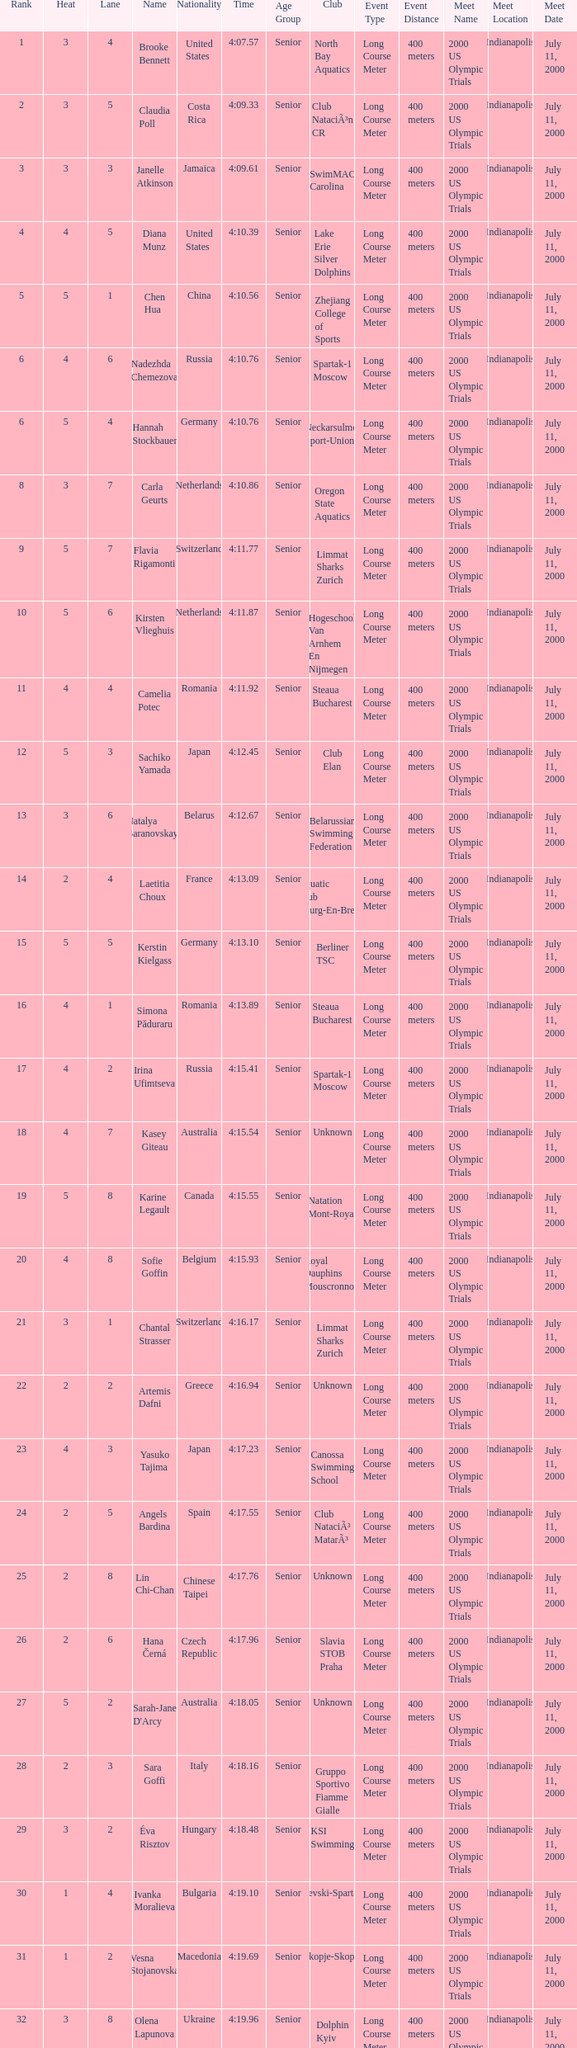Name the total number of lane for brooke bennett and rank less than 1 0.0. Give me the full table as a dictionary. {'header': ['Rank', 'Heat', 'Lane', 'Name', 'Nationality', 'Time', 'Age Group', 'Club', 'Event Type', 'Event Distance', 'Meet Name', 'Meet Location', 'Meet Date'], 'rows': [['1', '3', '4', 'Brooke Bennett', 'United States', '4:07.57', 'Senior', 'North Bay Aquatics', 'Long Course Meter', '400 meters', '2000 US Olympic Trials', 'Indianapolis', 'July 11, 2000'], ['2', '3', '5', 'Claudia Poll', 'Costa Rica', '4:09.33', 'Senior', 'Club NataciÃ³n CR', 'Long Course Meter', '400 meters', '2000 US Olympic Trials', 'Indianapolis', 'July 11, 2000'], ['3', '3', '3', 'Janelle Atkinson', 'Jamaica', '4:09.61', 'Senior', 'SwimMAC Carolina', 'Long Course Meter', '400 meters', '2000 US Olympic Trials', 'Indianapolis', 'July 11, 2000'], ['4', '4', '5', 'Diana Munz', 'United States', '4:10.39', 'Senior', 'Lake Erie Silver Dolphins', 'Long Course Meter', '400 meters', '2000 US Olympic Trials', 'Indianapolis', 'July 11, 2000'], ['5', '5', '1', 'Chen Hua', 'China', '4:10.56', 'Senior', 'Zhejiang College of Sports', 'Long Course Meter', '400 meters', '2000 US Olympic Trials', 'Indianapolis', 'July 11, 2000'], ['6', '4', '6', 'Nadezhda Chemezova', 'Russia', '4:10.76', 'Senior', 'Spartak-1 Moscow', 'Long Course Meter', '400 meters', '2000 US Olympic Trials', 'Indianapolis', 'July 11, 2000'], ['6', '5', '4', 'Hannah Stockbauer', 'Germany', '4:10.76', 'Senior', 'Neckarsulmer Sport-Union', 'Long Course Meter', '400 meters', '2000 US Olympic Trials', 'Indianapolis', 'July 11, 2000'], ['8', '3', '7', 'Carla Geurts', 'Netherlands', '4:10.86', 'Senior', 'Oregon State Aquatics', 'Long Course Meter', '400 meters', '2000 US Olympic Trials', 'Indianapolis', 'July 11, 2000'], ['9', '5', '7', 'Flavia Rigamonti', 'Switzerland', '4:11.77', 'Senior', 'Limmat Sharks Zurich', 'Long Course Meter', '400 meters', '2000 US Olympic Trials', 'Indianapolis', 'July 11, 2000'], ['10', '5', '6', 'Kirsten Vlieghuis', 'Netherlands', '4:11.87', 'Senior', 'Hogeschool Van Arnhem En Nijmegen', 'Long Course Meter', '400 meters', '2000 US Olympic Trials', 'Indianapolis', 'July 11, 2000'], ['11', '4', '4', 'Camelia Potec', 'Romania', '4:11.92', 'Senior', 'Steaua Bucharest', 'Long Course Meter', '400 meters', '2000 US Olympic Trials', 'Indianapolis', 'July 11, 2000'], ['12', '5', '3', 'Sachiko Yamada', 'Japan', '4:12.45', 'Senior', 'Club Elan', 'Long Course Meter', '400 meters', '2000 US Olympic Trials', 'Indianapolis', 'July 11, 2000'], ['13', '3', '6', 'Natalya Baranovskaya', 'Belarus', '4:12.67', 'Senior', 'Belarussian Swimming Federation', 'Long Course Meter', '400 meters', '2000 US Olympic Trials', 'Indianapolis', 'July 11, 2000'], ['14', '2', '4', 'Laetitia Choux', 'France', '4:13.09', 'Senior', 'Aquatic Club Bourg-En-Bresse', 'Long Course Meter', '400 meters', '2000 US Olympic Trials', 'Indianapolis', 'July 11, 2000'], ['15', '5', '5', 'Kerstin Kielgass', 'Germany', '4:13.10', 'Senior', 'Berliner TSC', 'Long Course Meter', '400 meters', '2000 US Olympic Trials', 'Indianapolis', 'July 11, 2000'], ['16', '4', '1', 'Simona Păduraru', 'Romania', '4:13.89', 'Senior', 'Steaua Bucharest', 'Long Course Meter', '400 meters', '2000 US Olympic Trials', 'Indianapolis', 'July 11, 2000'], ['17', '4', '2', 'Irina Ufimtseva', 'Russia', '4:15.41', 'Senior', 'Spartak-1 Moscow', 'Long Course Meter', '400 meters', '2000 US Olympic Trials', 'Indianapolis', 'July 11, 2000'], ['18', '4', '7', 'Kasey Giteau', 'Australia', '4:15.54', 'Senior', 'Unknown', 'Long Course Meter', '400 meters', '2000 US Olympic Trials', 'Indianapolis', 'July 11, 2000'], ['19', '5', '8', 'Karine Legault', 'Canada', '4:15.55', 'Senior', 'Natation Mont-Royal', 'Long Course Meter', '400 meters', '2000 US Olympic Trials', 'Indianapolis', 'July 11, 2000'], ['20', '4', '8', 'Sofie Goffin', 'Belgium', '4:15.93', 'Senior', 'Royal Dauphins Mouscronnois', 'Long Course Meter', '400 meters', '2000 US Olympic Trials', 'Indianapolis', 'July 11, 2000'], ['21', '3', '1', 'Chantal Strasser', 'Switzerland', '4:16.17', 'Senior', 'Limmat Sharks Zurich', 'Long Course Meter', '400 meters', '2000 US Olympic Trials', 'Indianapolis', 'July 11, 2000'], ['22', '2', '2', 'Artemis Dafni', 'Greece', '4:16.94', 'Senior', 'Unknown', 'Long Course Meter', '400 meters', '2000 US Olympic Trials', 'Indianapolis', 'July 11, 2000'], ['23', '4', '3', 'Yasuko Tajima', 'Japan', '4:17.23', 'Senior', 'Canossa Swimming School', 'Long Course Meter', '400 meters', '2000 US Olympic Trials', 'Indianapolis', 'July 11, 2000'], ['24', '2', '5', 'Angels Bardina', 'Spain', '4:17.55', 'Senior', 'Club NataciÃ³ MatarÃ³', 'Long Course Meter', '400 meters', '2000 US Olympic Trials', 'Indianapolis', 'July 11, 2000'], ['25', '2', '8', 'Lin Chi-Chan', 'Chinese Taipei', '4:17.76', 'Senior', 'Unknown', 'Long Course Meter', '400 meters', '2000 US Olympic Trials', 'Indianapolis', 'July 11, 2000'], ['26', '2', '6', 'Hana Černá', 'Czech Republic', '4:17.96', 'Senior', 'Slavia STOB Praha', 'Long Course Meter', '400 meters', '2000 US Olympic Trials', 'Indianapolis', 'July 11, 2000'], ['27', '5', '2', "Sarah-Jane D'Arcy", 'Australia', '4:18.05', 'Senior', 'Unknown', 'Long Course Meter', '400 meters', '2000 US Olympic Trials', 'Indianapolis', 'July 11, 2000'], ['28', '2', '3', 'Sara Goffi', 'Italy', '4:18.16', 'Senior', 'Gruppo Sportivo Fiamme Gialle', 'Long Course Meter', '400 meters', '2000 US Olympic Trials', 'Indianapolis', 'July 11, 2000'], ['29', '3', '2', 'Éva Risztov', 'Hungary', '4:18.48', 'Senior', 'KSI Swimming', 'Long Course Meter', '400 meters', '2000 US Olympic Trials', 'Indianapolis', 'July 11, 2000'], ['30', '1', '4', 'Ivanka Moralieva', 'Bulgaria', '4:19.10', 'Senior', 'Levski-Spartak', 'Long Course Meter', '400 meters', '2000 US Olympic Trials', 'Indianapolis', 'July 11, 2000'], ['31', '1', '2', 'Vesna Stojanovska', 'Macedonia', '4:19.69', 'Senior', 'Skopje-Skopje', 'Long Course Meter', '400 meters', '2000 US Olympic Trials', 'Indianapolis', 'July 11, 2000'], ['32', '3', '8', 'Olena Lapunova', 'Ukraine', '4:19.96', 'Senior', 'Dolphin Kyiv', 'Long Course Meter', '400 meters', '2000 US Olympic Trials', 'Indianapolis', 'July 11, 2000'], ['33', '1', '3', 'Patricia Villarreal', 'Mexico', '4:21.03', 'Senior', 'Unknown', 'Long Course Meter', '400 meters', '2000 US Olympic Trials', 'Indianapolis', 'July 11, 2000'], ['34', '1', '7', 'Chantal Gibney', 'Ireland', '4:23.73', 'Senior', 'Trojan SC', 'Long Course Meter', '400 meters', '2000 US Olympic Trials', 'Indianapolis', 'July 11, 2000'], ['35', '1', '1', 'Nataliya Korabelnikova', 'Kyrgyzstan', '4:24.29', 'Senior', 'Unknown', 'Long Course Meter', '400 meters', '2000 US Olympic Trials', 'Indianapolis', 'July 11, 2000'], ['36', '1', '5', 'Christel Bouvron', 'Singapore', '4:25.16', 'Senior', 'Aquatic Performance Swim Club', 'Long Course Meter', '400 meters', '2000 US Olympic Trials', 'Indianapolis', 'July 11, 2000'], ['37', '2', '1', 'Roh Joo-Hee', 'South Korea', '4:25.66', 'Senior', 'Unknown', 'Long Course Meter', '400 meters', '2000 US Olympic Trials', 'Indianapolis', 'July 11, 2000'], ['38', '1', '6', 'Adi Bichman', 'Israel', '4:27.33', 'Senior', 'Hapoel Jerusalem', 'Long Course Meter', '400 meters', '2000 US Olympic Trials', 'Indianapolis', 'July 11, 2000'], ['39', '2', '7', 'Pilin Tachakittiranan', 'Thailand', '4:29.28', 'Senior', 'Unknown', 'Long Course Meter', '400 meters', '2000 US Olympic Trials', 'Indianapolis', 'July 11, 2000']]} 